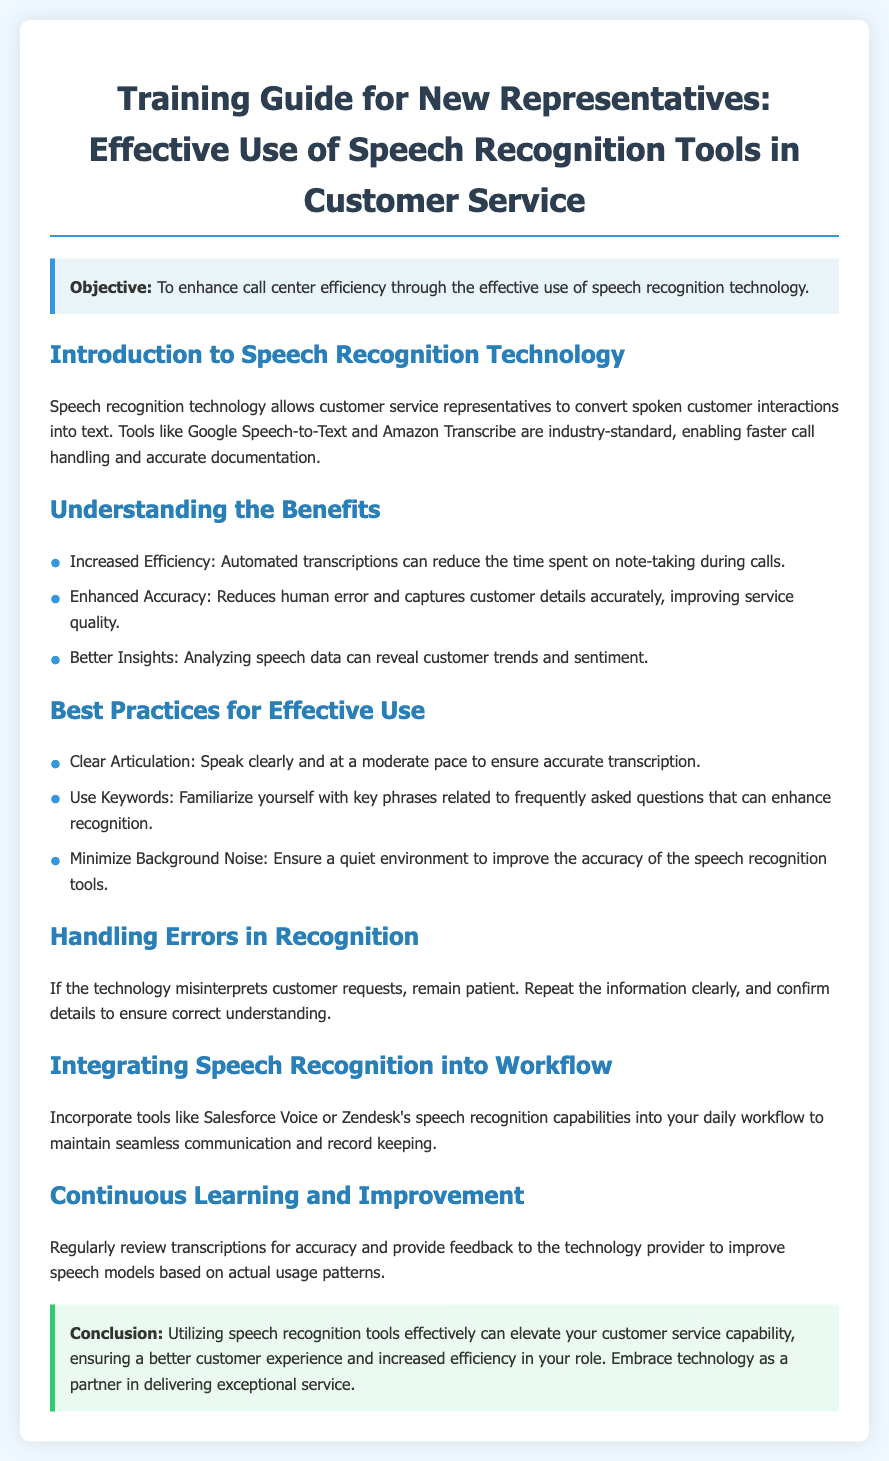What is the objective of the training guide? The objective is to enhance call center efficiency through the effective use of speech recognition technology.
Answer: Enhance call center efficiency What is a benefit of using speech recognition technology? One benefit listed is reduced time spent on note-taking during calls.
Answer: Increased Efficiency Which tools are mentioned for speech recognition? The document references Google Speech-to-Text and Amazon Transcribe as industry-standard tools.
Answer: Google Speech-to-Text and Amazon Transcribe What should representatives do to improve transcription accuracy? Representatives should speak clearly and at a moderate pace to ensure accurate transcription.
Answer: Clear Articulation What is recommended to minimize recognition errors? It is recommended to repeat the information clearly and confirm details for correct understanding.
Answer: Repeat the information clearly How can speech recognition tools be integrated into daily work? Tools like Salesforce Voice or Zendesk's speech recognition capabilities can be incorporated into daily workflow.
Answer: Salesforce Voice or Zendesk's speech recognition capabilities What is the focus of the "Continuous Learning and Improvement" section? The focus is on reviewing transcriptions for accuracy and providing feedback to the technology provider.
Answer: Reviewing transcriptions for accuracy What color highlights the conclusion section? The conclusion section is highlighted with a background color of light green.
Answer: Light green 